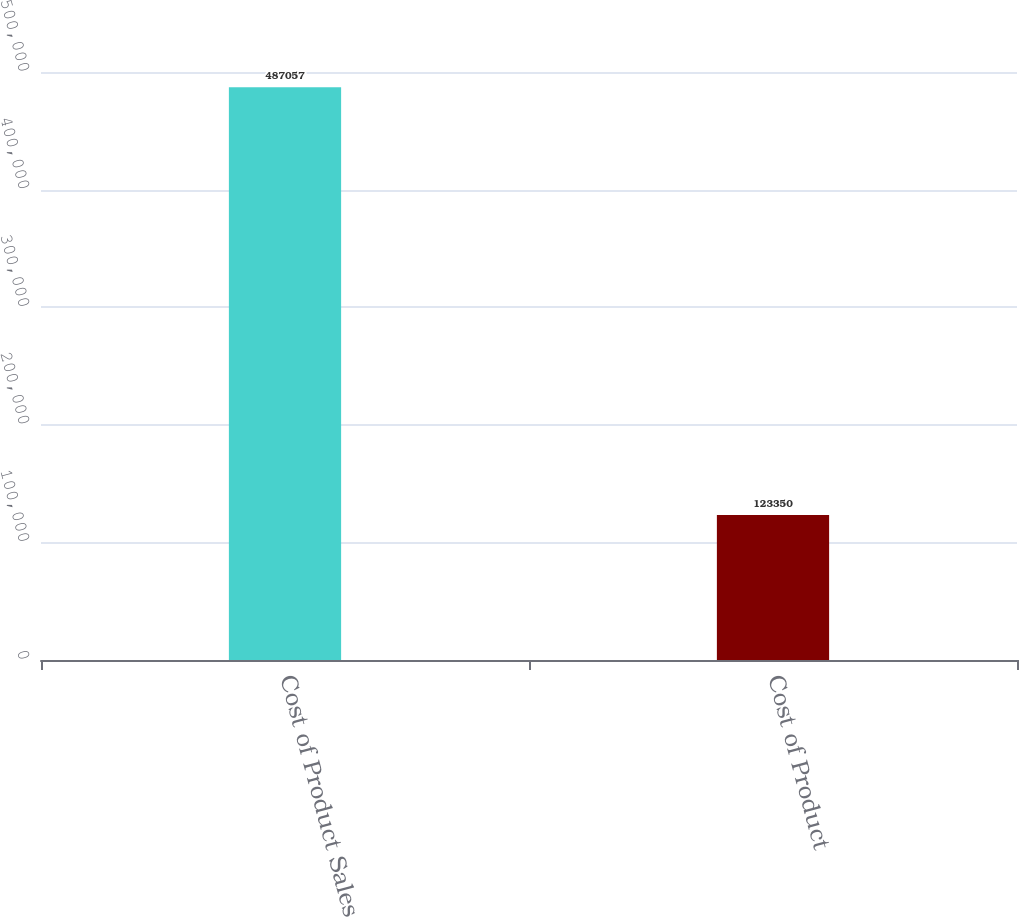Convert chart. <chart><loc_0><loc_0><loc_500><loc_500><bar_chart><fcel>Cost of Product Sales<fcel>Cost of Product<nl><fcel>487057<fcel>123350<nl></chart> 